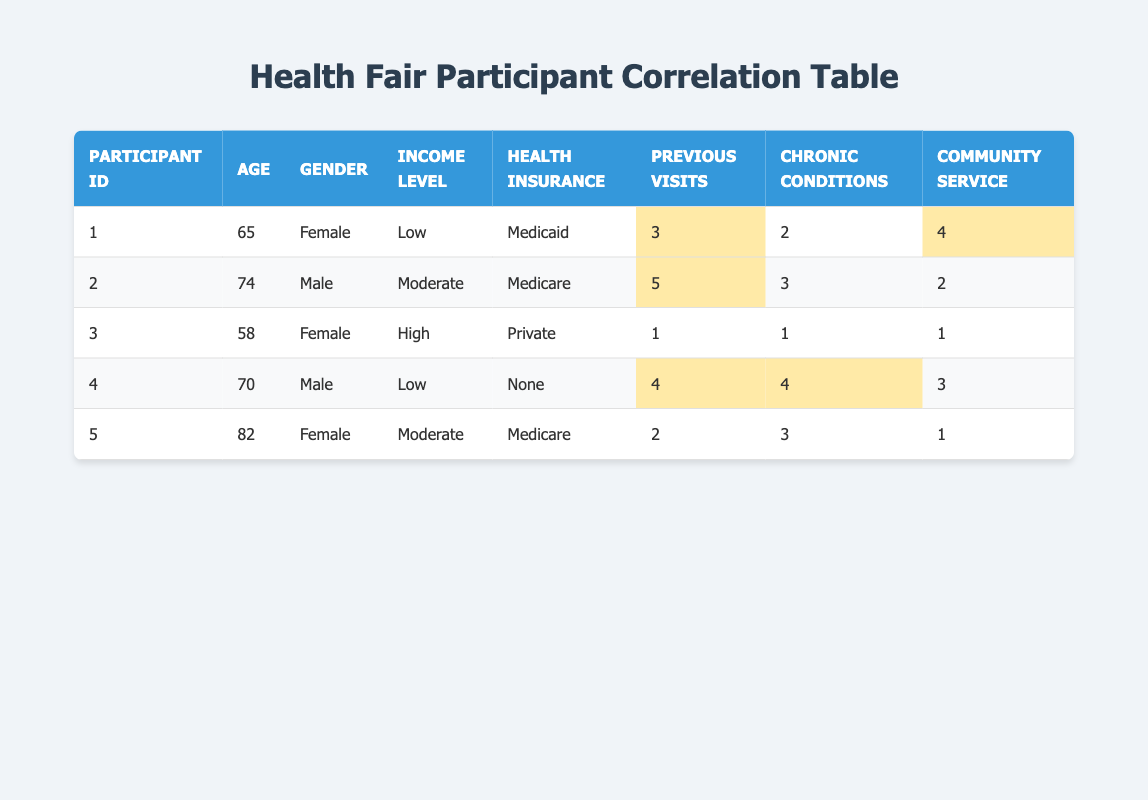What is the age of the participant with the highest number of previous health fair visits? The participant with the highest number of previous health fair visits is participant ID 2, who has 5 visits. Referring to the table, this participant's age is 74.
Answer: 74 What income level does the participant with the most chronic conditions have? The participant with the most chronic conditions is participant ID 4, who has 4 chronic conditions. Referring to the table, this participant's income level is Low.
Answer: Low Is there a participant that has both a low income level and a high number of previous visits? Looking at the table, participant ID 1 and participant ID 4 both have a low income level. However, participant ID 1 has 3 previous visits, while participant ID 4 has 4 previous visits. Therefore, both participants meet the criteria.
Answer: Yes What is the average number of previous health fair visits among participants? The total number of previous visits is 3 + 5 + 1 + 4 + 2 = 15. There are 5 participants, so the average is 15 divided by 5, which equals 3.
Answer: 3 Which gender has participants with the highest total of community service involvement? Male participants are IDs 2 and 4, with community service involvement scores of 2 and 3, respectively, totaling 5. Female participants are IDs 1, 3, and 5, with scores of 4, 1, and 1, respectively, totaling 6. Therefore, the female participants have a higher total.
Answer: Female What is the income level of the participant with the second-highest chronic conditions? The participant with the second-highest chronic conditions is participant ID 5, who has 3 chronic conditions (the highest being participant ID 4 with 4). Referring to the table, participant ID 5 has a Moderate income level.
Answer: Moderate Is it true that all participants with Medicaid have more than 2 previous visits? Looking at the table, only participant ID 1 has Medicaid, and this participant has 3 previous visits. Therefore, the statement is true.
Answer: Yes How many participants have health insurance and have never attended a health fair before? Referring to the table, health insurance types vary among the participants. However, participant ID 3 has Private health insurance and has only one previous visit, which is not zero, while no participant is indicated as having never attended a health fair. Therefore, the answer is none.
Answer: None Among the male participants, who has the least number of chronic conditions? There are 2 male participants, ID 2 with 3 chronic conditions and ID 4 with 4 chronic conditions. Since 3 is less than 4, participant ID 2 has the least number of chronic conditions.
Answer: Participant ID 2 